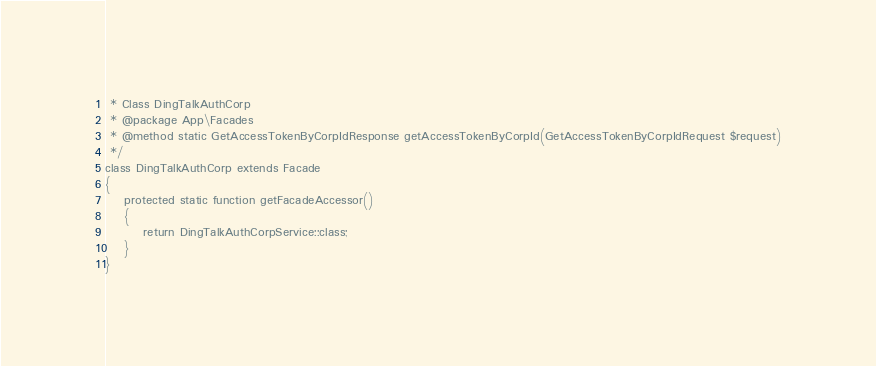Convert code to text. <code><loc_0><loc_0><loc_500><loc_500><_PHP_> * Class DingTalkAuthCorp
 * @package App\Facades
 * @method static GetAccessTokenByCorpIdResponse getAccessTokenByCorpId(GetAccessTokenByCorpIdRequest $request)
 */
class DingTalkAuthCorp extends Facade
{
    protected static function getFacadeAccessor()
    {
        return DingTalkAuthCorpService::class;
    }
}
</code> 